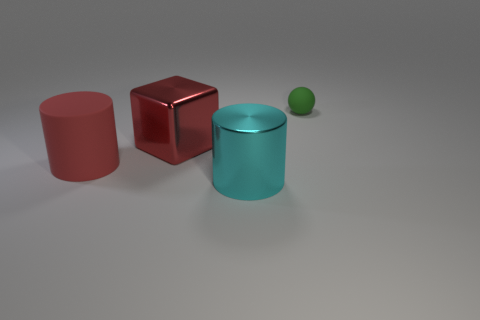Add 2 red metal cubes. How many objects exist? 6 Subtract all spheres. How many objects are left? 3 Add 2 big cyan metallic cylinders. How many big cyan metallic cylinders are left? 3 Add 4 large shiny things. How many large shiny things exist? 6 Subtract 0 purple balls. How many objects are left? 4 Subtract all large cubes. Subtract all tiny green things. How many objects are left? 2 